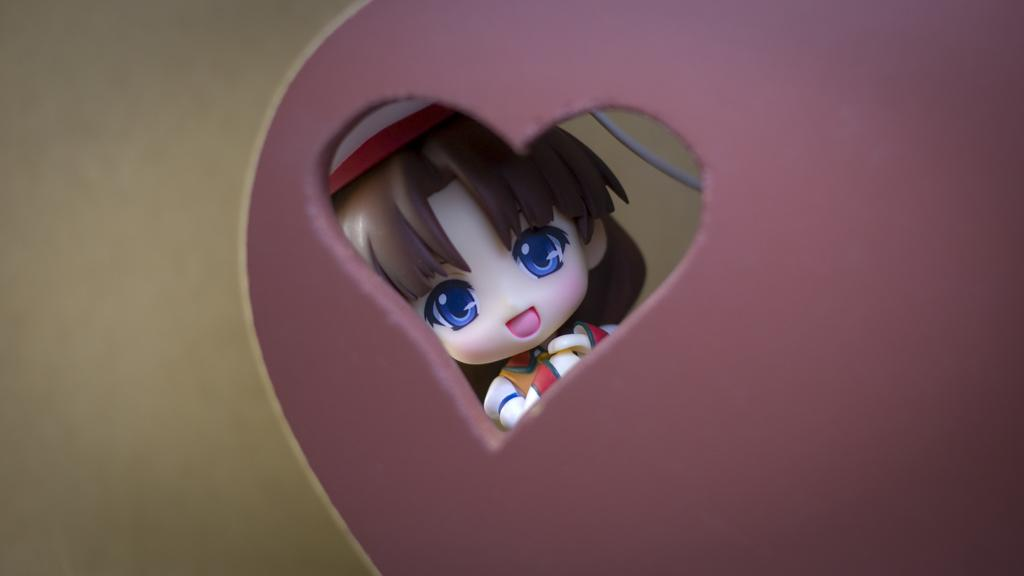What type of toy is present in the image? There is a toy of a girl in the image. What else can be seen in the image besides the toy? There is a wire and some objects in the image. What type of drug is the girl taking in the image? There is no drug present in the image; it features a toy of a girl and other objects. Is there a chessboard visible in the image? There is no chessboard or any indication of a chess game in the image. 